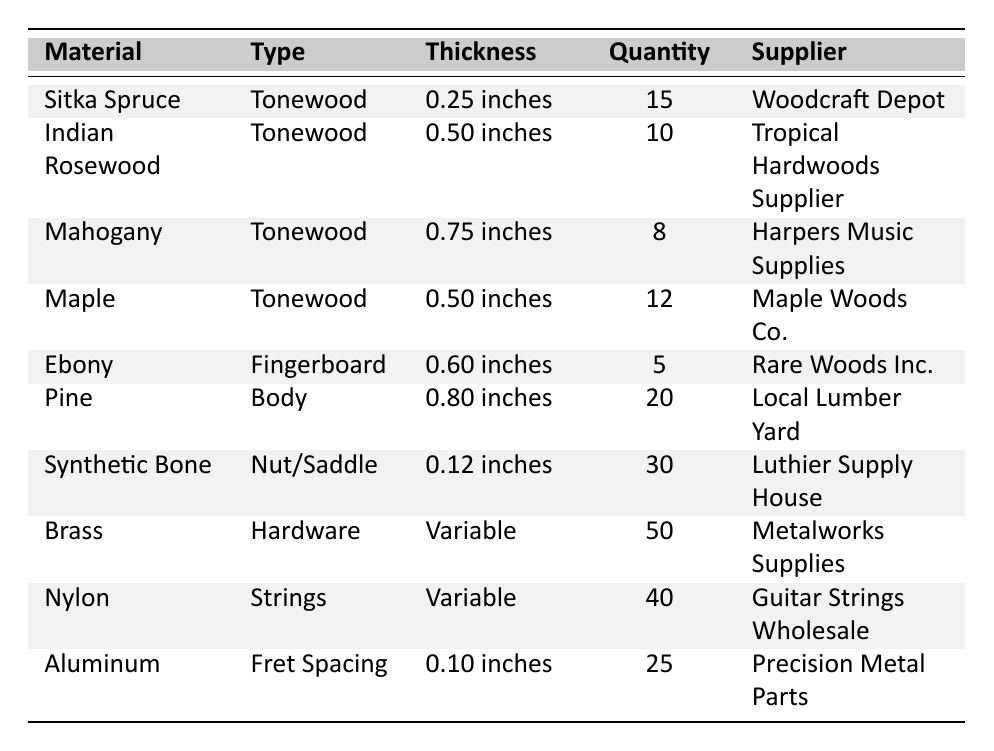What is the quantity of Sitka Spruce available? The table shows that Sitka Spruce has a quantity of 15 listed under the Quantity column.
Answer: 15 What type of material is Indian Rosewood? Indian Rosewood is categorized as a Tonewood, which is indicated in the Type column of the table.
Answer: Tonewood How many pieces of Ebony are in stock? The quantity of Ebony listed in the table is 5, as stated in the Quantity column.
Answer: 5 What is the thickness of Aluminum used for fret spacing? The table indicates that the thickness of Aluminum is 0.10 inches, specifically mentioned in the Thickness column.
Answer: 0.10 inches Which supplier provides Synthetic Bone? The supplier for Synthetic Bone is noted as Luthier Supply House in the Supplier column.
Answer: Luthier Supply House What is the total quantity of tonewood materials available? The total quantity of tonewoods (Sitka Spruce, Indian Rosewood, Mahogany, and Maple) is calculated as 15 + 10 + 8 + 12 = 45.
Answer: 45 Which material has the largest quantity available? By comparing the quantities in the table, Brass has the largest quantity at 50, which is greater than all other materials listed.
Answer: Brass Is there more Pine than Indian Rosewood in stock? Pine has a quantity of 20 while Indian Rosewood has a quantity of 10, so Pine is indeed more abundant than Indian Rosewood.
Answer: Yes What is the difference in thickness between the thinnest and thickest tonewood? The thinnest tonewood is Sitka Spruce at 0.25 inches and the thickest is Mahogany at 0.75 inches. The difference is 0.75 - 0.25 = 0.50 inches.
Answer: 0.50 inches How many more Synthetic Bone pieces are there than Ebony? The table shows 30 pieces of Synthetic Bone and 5 pieces of Ebony. The difference is 30 - 5 = 25.
Answer: 25 